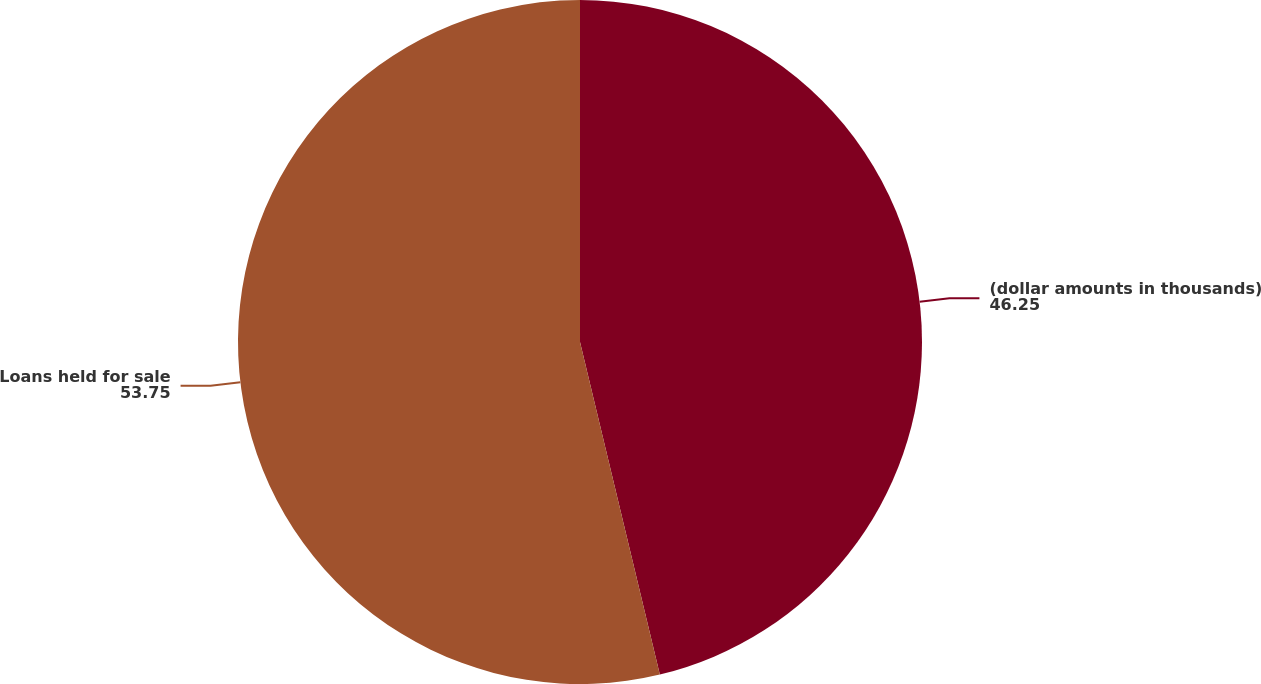Convert chart. <chart><loc_0><loc_0><loc_500><loc_500><pie_chart><fcel>(dollar amounts in thousands)<fcel>Loans held for sale<nl><fcel>46.25%<fcel>53.75%<nl></chart> 